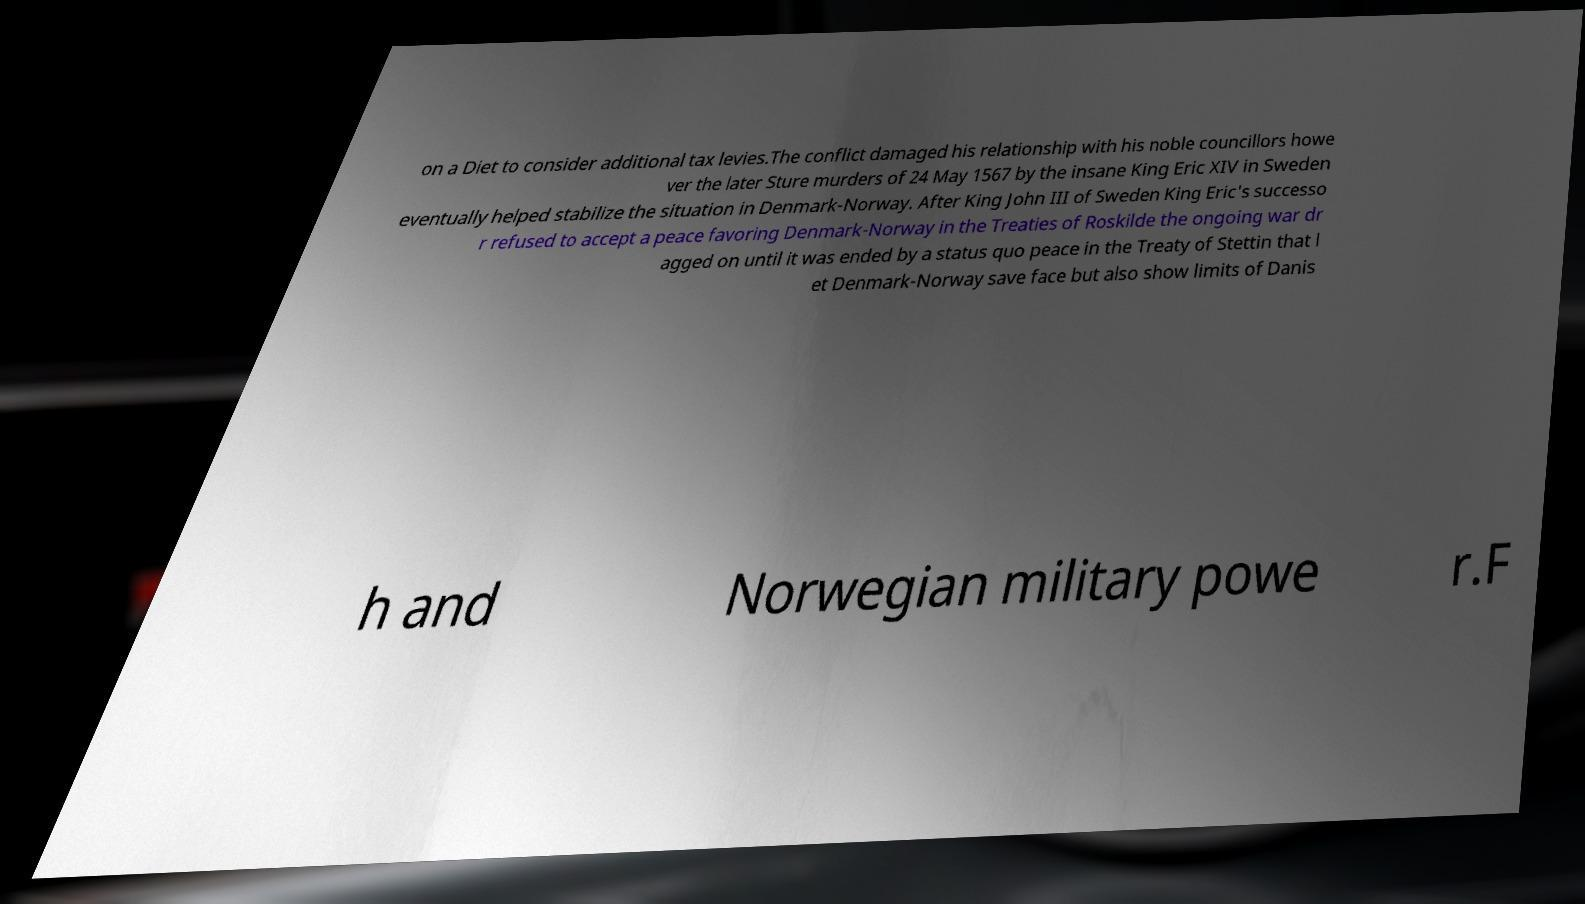Could you assist in decoding the text presented in this image and type it out clearly? on a Diet to consider additional tax levies.The conflict damaged his relationship with his noble councillors howe ver the later Sture murders of 24 May 1567 by the insane King Eric XIV in Sweden eventually helped stabilize the situation in Denmark-Norway. After King John III of Sweden King Eric's successo r refused to accept a peace favoring Denmark-Norway in the Treaties of Roskilde the ongoing war dr agged on until it was ended by a status quo peace in the Treaty of Stettin that l et Denmark-Norway save face but also show limits of Danis h and Norwegian military powe r.F 